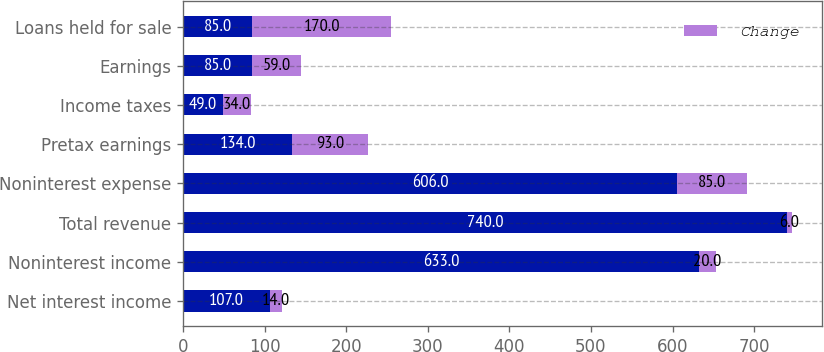Convert chart to OTSL. <chart><loc_0><loc_0><loc_500><loc_500><stacked_bar_chart><ecel><fcel>Net interest income<fcel>Noninterest income<fcel>Total revenue<fcel>Noninterest expense<fcel>Pretax earnings<fcel>Income taxes<fcel>Earnings<fcel>Loans held for sale<nl><fcel>nan<fcel>107<fcel>633<fcel>740<fcel>606<fcel>134<fcel>49<fcel>85<fcel>85<nl><fcel>Change<fcel>14<fcel>20<fcel>6<fcel>85<fcel>93<fcel>34<fcel>59<fcel>170<nl></chart> 